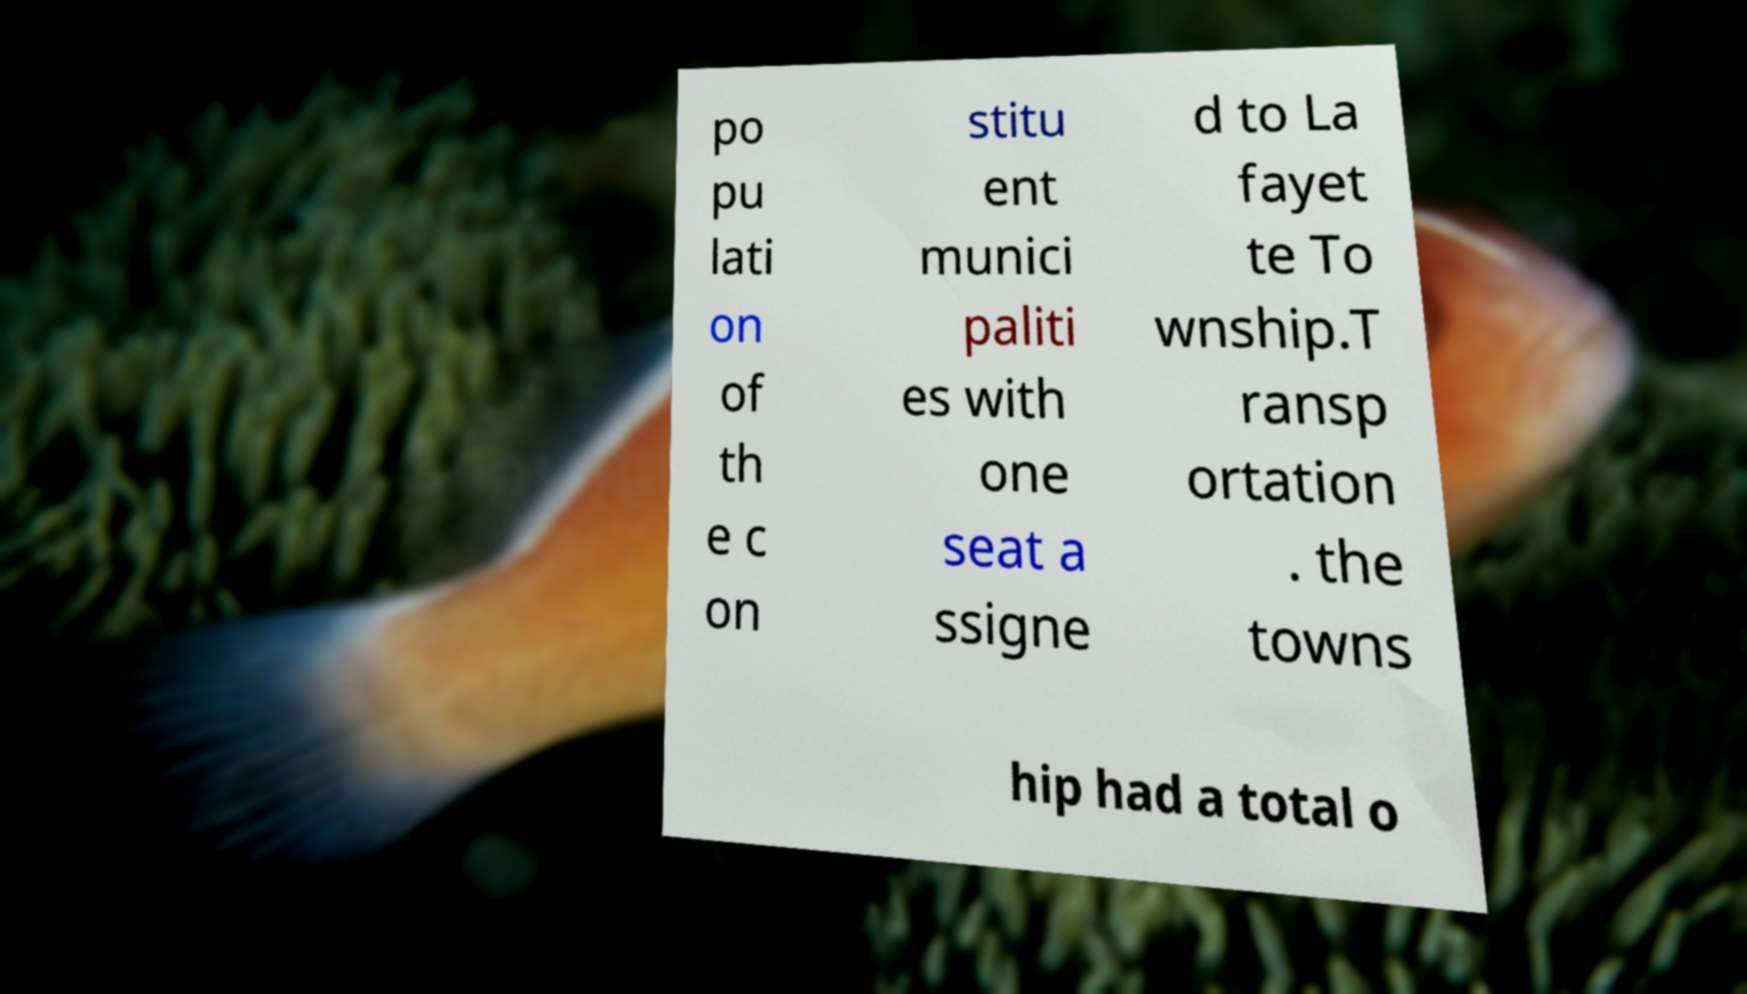I need the written content from this picture converted into text. Can you do that? po pu lati on of th e c on stitu ent munici paliti es with one seat a ssigne d to La fayet te To wnship.T ransp ortation . the towns hip had a total o 